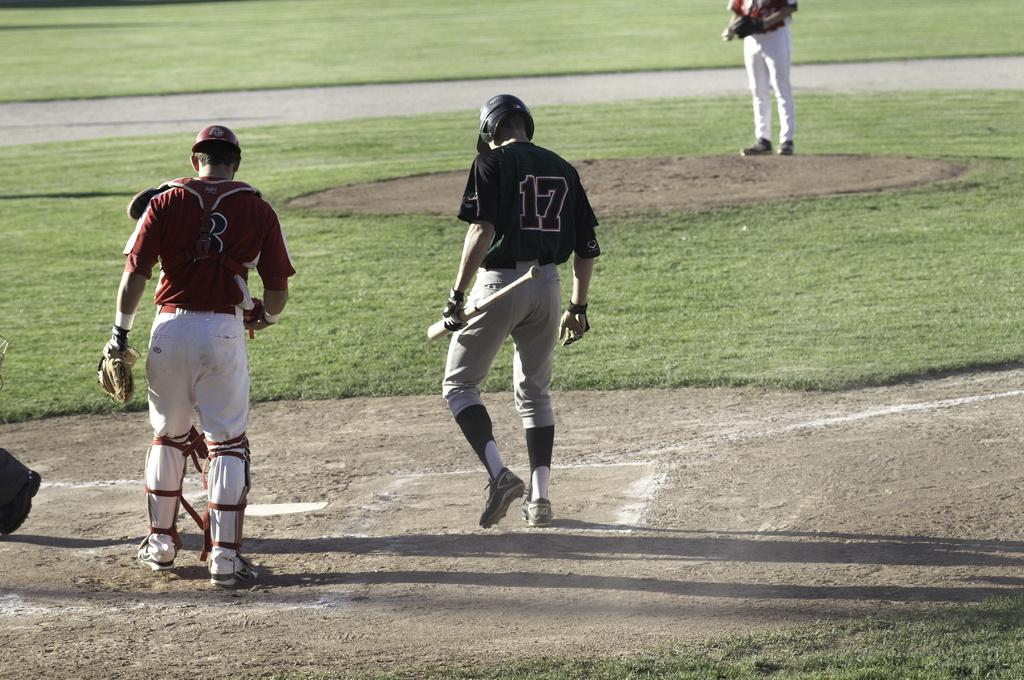<image>
Render a clear and concise summary of the photo. Player number 17 holds a bat as he approaches home plate. 